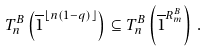Convert formula to latex. <formula><loc_0><loc_0><loc_500><loc_500>T ^ { B } _ { n } \left ( \overline { 1 } ^ { \lfloor n ( 1 - q ) \rfloor } \right ) \subseteq T ^ { B } _ { n } \left ( \overline { 1 } ^ { R ^ { B } _ { m } } \right ) \, .</formula> 